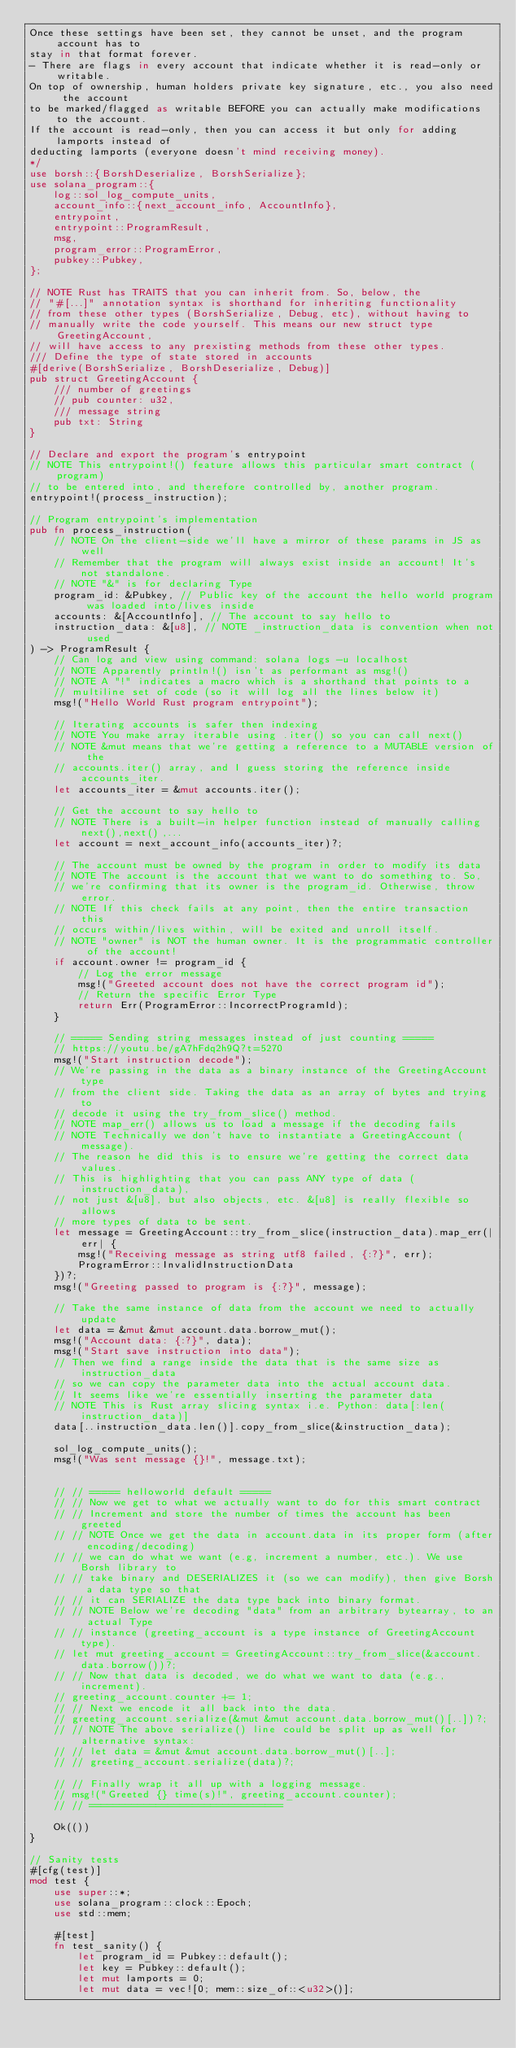<code> <loc_0><loc_0><loc_500><loc_500><_Rust_>Once these settings have been set, they cannot be unset, and the program account has to
stay in that format forever. 
- There are flags in every account that indicate whether it is read-only or writable.
On top of ownership, human holders private key signature, etc., you also need the account
to be marked/flagged as writable BEFORE you can actually make modifications to the account.
If the account is read-only, then you can access it but only for adding lamports instead of
deducting lamports (everyone doesn't mind receiving money).
*/
use borsh::{BorshDeserialize, BorshSerialize};
use solana_program::{
    log::sol_log_compute_units,
    account_info::{next_account_info, AccountInfo},
    entrypoint,
    entrypoint::ProgramResult,
    msg,
    program_error::ProgramError,
    pubkey::Pubkey,
};

// NOTE Rust has TRAITS that you can inherit from. So, below, the
// "#[...]" annotation syntax is shorthand for inheriting functionality
// from these other types (BorshSerialize, Debug, etc), without having to
// manually write the code yourself. This means our new struct type GreetingAccount,
// will have access to any prexisting methods from these other types.
/// Define the type of state stored in accounts
#[derive(BorshSerialize, BorshDeserialize, Debug)]
pub struct GreetingAccount {
    /// number of greetings
    // pub counter: u32,
    /// message string
    pub txt: String
}

// Declare and export the program's entrypoint
// NOTE This entrypoint!() feature allows this particular smart contract (program)
// to be entered into, and therefore controlled by, another program.
entrypoint!(process_instruction);

// Program entrypoint's implementation
pub fn process_instruction(
    // NOTE On the client-side we'll have a mirror of these params in JS as well
    // Remember that the program will always exist inside an account! It's not standalone.
    // NOTE "&" is for declaring Type
    program_id: &Pubkey, // Public key of the account the hello world program was loaded into/lives inside
    accounts: &[AccountInfo], // The account to say hello to
    instruction_data: &[u8], // NOTE _instruction_data is convention when not used
) -> ProgramResult {
    // Can log and view using command: solana logs -u localhost
    // NOTE Apparently println!() isn't as performant as msg!()
    // NOTE A "!" indicates a macro which is a shorthand that points to a
    // multiline set of code (so it will log all the lines below it)
    msg!("Hello World Rust program entrypoint");

    // Iterating accounts is safer then indexing
    // NOTE You make array iterable using .iter() so you can call next()
    // NOTE &mut means that we're getting a reference to a MUTABLE version of the
    // accounts.iter() array, and I guess storing the reference inside accounts_iter.
    let accounts_iter = &mut accounts.iter();

    // Get the account to say hello to
    // NOTE There is a built-in helper function instead of manually calling next(),next(),...
    let account = next_account_info(accounts_iter)?;

    // The account must be owned by the program in order to modify its data
    // NOTE The account is the account that we want to do something to. So,
    // we're confirming that its owner is the program_id. Otherwise, throw error.
    // NOTE If this check fails at any point, then the entire transaction this
    // occurs within/lives within, will be exited and unroll itself.
    // NOTE "owner" is NOT the human owner. It is the programmatic controller of the account!
    if account.owner != program_id {
        // Log the error message
        msg!("Greeted account does not have the correct program id");
        // Return the specific Error Type
        return Err(ProgramError::IncorrectProgramId);
    }

    // ===== Sending string messages instead of just counting =====
    // https://youtu.be/gA7hFdq2h9Q?t=5270
    msg!("Start instruction decode");
    // We're passing in the data as a binary instance of the GreetingAccount type
    // from the client side. Taking the data as an array of bytes and trying to
    // decode it using the try_from_slice() method.
    // NOTE map_err() allows us to load a message if the decoding fails
    // NOTE Technically we don't have to instantiate a GreetingAccount (message).
    // The reason he did this is to ensure we're getting the correct data values.
    // This is highlighting that you can pass ANY type of data (instruction_data),
    // not just &[u8], but also objects, etc. &[u8] is really flexible so allows
    // more types of data to be sent.
    let message = GreetingAccount::try_from_slice(instruction_data).map_err(|err| {
        msg!("Receiving message as string utf8 failed, {:?}", err);
        ProgramError::InvalidInstructionData
    })?;
    msg!("Greeting passed to program is {:?}", message);

    // Take the same instance of data from the account we need to actually update
    let data = &mut &mut account.data.borrow_mut();
    msg!("Account data: {:?}", data);
    msg!("Start save instruction into data");
    // Then we find a range inside the data that is the same size as instruction_data
    // so we can copy the parameter data into the actual account data.
    // It seems like we're essentially inserting the parameter data
    // NOTE This is Rust array slicing syntax i.e. Python: data[:len(instruction_data)]
    data[..instruction_data.len()].copy_from_slice(&instruction_data);
    
    sol_log_compute_units();
    msg!("Was sent message {}!", message.txt);


    // // ===== helloworld default =====
    // // Now we get to what we actually want to do for this smart contract
    // // Increment and store the number of times the account has been greeted
    // // NOTE Once we get the data in account.data in its proper form (after encoding/decoding)
    // // we can do what we want (e.g, increment a number, etc.). We use Borsh library to
    // // take binary and DESERIALIZES it (so we can modify), then give Borsh a data type so that
    // // it can SERIALIZE the data type back into binary format.
    // // NOTE Below we're decoding "data" from an arbitrary bytearray, to an actual Type
    // // instance (greeting_account is a type instance of GreetingAccount type).
    // let mut greeting_account = GreetingAccount::try_from_slice(&account.data.borrow())?;
    // // Now that data is decoded, we do what we want to data (e.g., increment).
    // greeting_account.counter += 1;
    // // Next we encode it all back into the data.
    // greeting_account.serialize(&mut &mut account.data.borrow_mut()[..])?;
    // // NOTE The above serialize() line could be split up as well for alternative syntax:
    // // let data = &mut &mut account.data.borrow_mut()[..];
    // // greeting_account.serialize(data)?;

    // // Finally wrap it all up with a logging message.
    // msg!("Greeted {} time(s)!", greeting_account.counter);
    // // ================================

    Ok(())
}

// Sanity tests
#[cfg(test)]
mod test {
    use super::*;
    use solana_program::clock::Epoch;
    use std::mem;

    #[test]
    fn test_sanity() {
        let program_id = Pubkey::default();
        let key = Pubkey::default();
        let mut lamports = 0;
        let mut data = vec![0; mem::size_of::<u32>()];</code> 